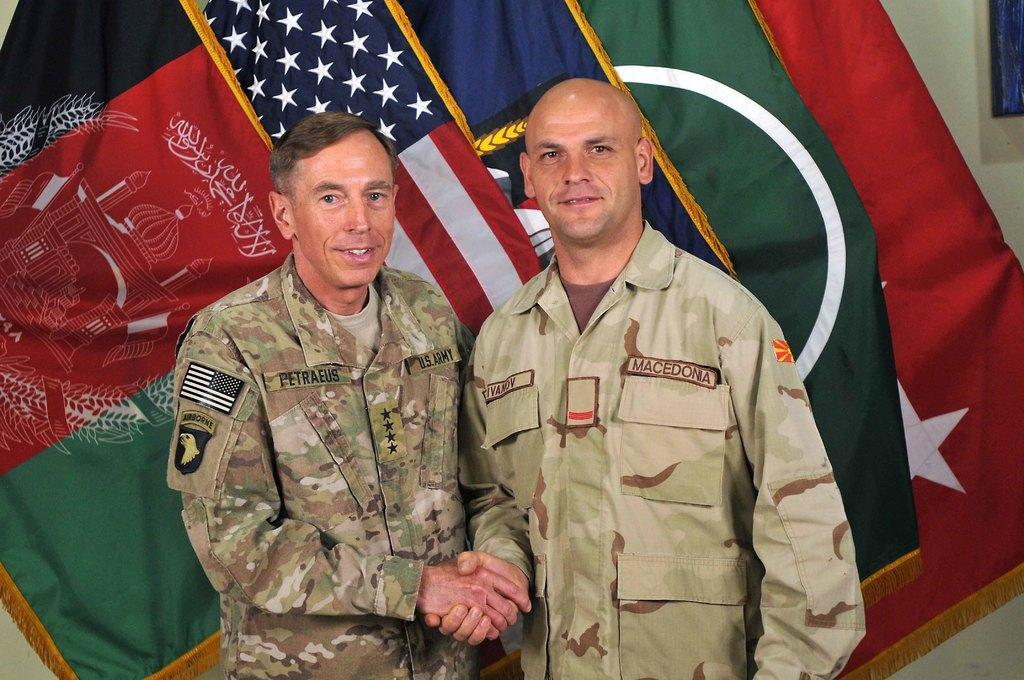Can you describe this image briefly? This image consists of two persons. They are wearing military dresses. There are flags behind them. 